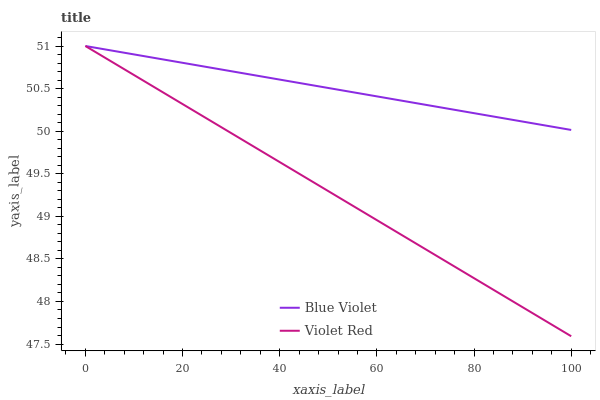Does Violet Red have the minimum area under the curve?
Answer yes or no. Yes. Does Blue Violet have the maximum area under the curve?
Answer yes or no. Yes. Does Blue Violet have the minimum area under the curve?
Answer yes or no. No. Is Violet Red the smoothest?
Answer yes or no. Yes. Is Blue Violet the roughest?
Answer yes or no. Yes. Is Blue Violet the smoothest?
Answer yes or no. No. Does Violet Red have the lowest value?
Answer yes or no. Yes. Does Blue Violet have the lowest value?
Answer yes or no. No. Does Blue Violet have the highest value?
Answer yes or no. Yes. Does Blue Violet intersect Violet Red?
Answer yes or no. Yes. Is Blue Violet less than Violet Red?
Answer yes or no. No. Is Blue Violet greater than Violet Red?
Answer yes or no. No. 